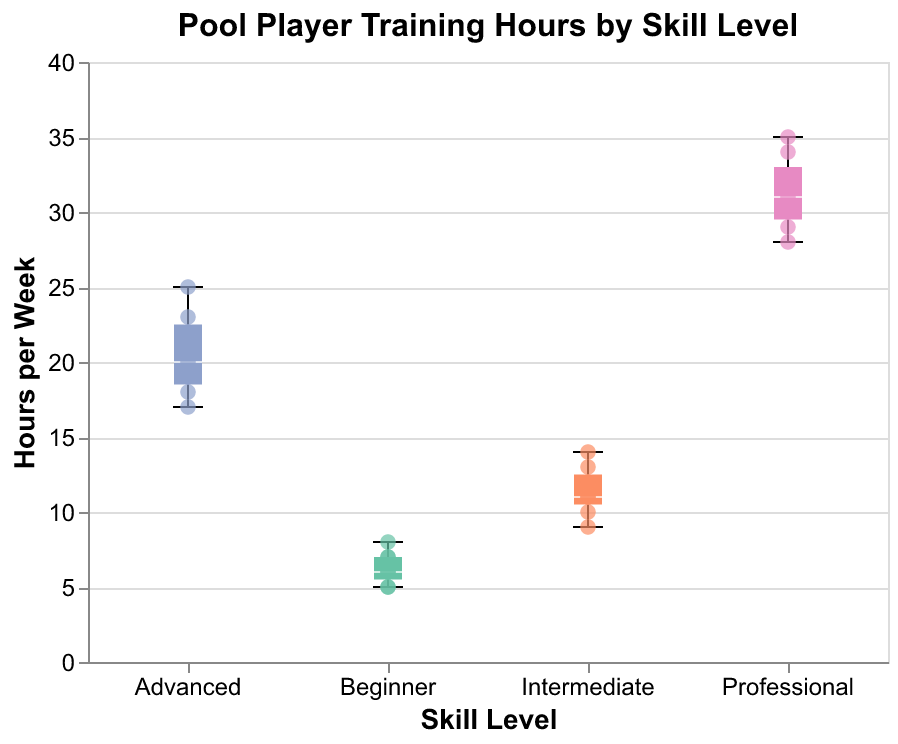What is the title of the figure? The title is usually located at the top of the figure. Here, it states "Pool Player Training Hours by Skill Level."
Answer: Pool Player Training Hours by Skill Level What is the range of training hours per week for Professional players? Look at the box plot for the Professional group. The whiskers represent the minimum and maximum values. Here, the range is from 28 to 35 hours.
Answer: 28 to 35 hours How many total data points are there for Intermediate players? Count the scatter points overlaid on the box plot for Intermediate players. There are seven data points for Intermediate players.
Answer: 7 Which skill level has the highest median training hours per week? The median is indicated by the line in the middle of the box. The Professional group has the highest median, which appears around 31.5 hours per week.
Answer: Professional What is the interquartile range (IQR) for Advanced players? The IQR is the range between the first quartile (Q1) and the third quartile (Q3). For Advanced players, Q1 is around 18 and Q3 is around 23, so IQR = 23 - 18 = 5 hours.
Answer: 5 hours Which skill level group shows the most variability in training hours per week? The most variability can be identified by the length of the whiskers. The Professional group’s training hours vary the most from 28 to 35 hours, indicating the largest spread.
Answer: Professional How do the median training hours for Intermediate players compare to those of Beginner players? The median for Intermediate players is higher than that for Beginner players. Intermediate players' median is around 11 hours, while Beginner players' median is around 6 hours.
Answer: Higher What's the difference between the maximum training hours of Intermediate and Beginner players? The maximum value of Intermediate players is 14 hours, and for Beginner players, it's 8 hours. The difference is 14 - 8 = 6 hours.
Answer: 6 hours Which skill level has the smallest maximum training hours per week? By comparing the upper whiskers, the Beginner level has the smallest maximum training hours per week at 8 hours.
Answer: Beginner 